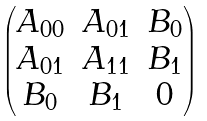Convert formula to latex. <formula><loc_0><loc_0><loc_500><loc_500>\begin{pmatrix} A _ { 0 0 } & A _ { 0 1 } & B _ { 0 } \\ A _ { 0 1 } & A _ { 1 1 } & B _ { 1 } \\ B _ { 0 } & B _ { 1 } & 0 \end{pmatrix}</formula> 